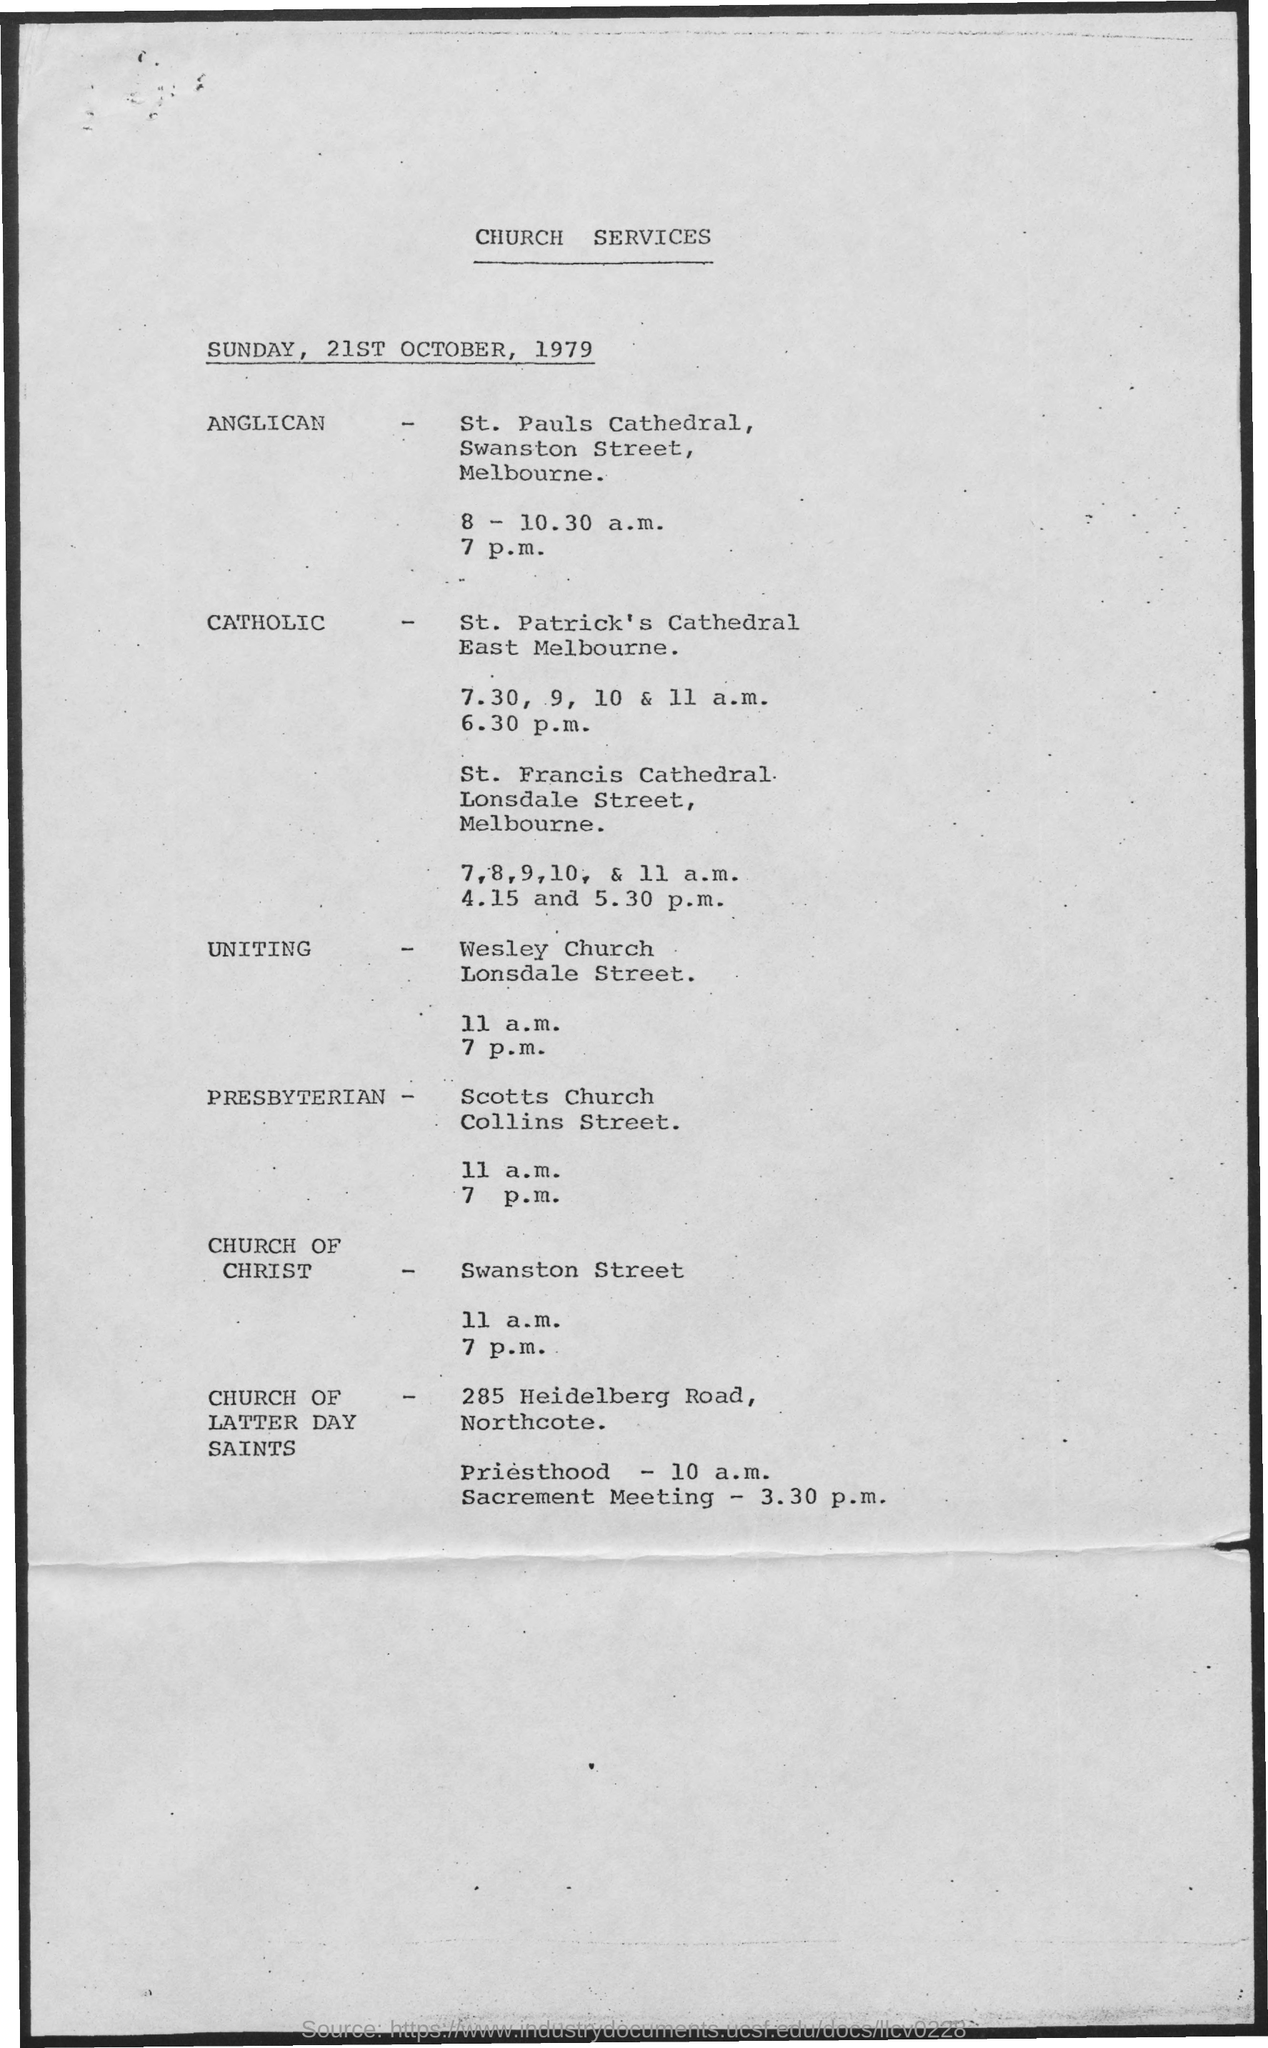What is the heading of document on top?
Ensure brevity in your answer.  Church Services. What day of the week is mentioned in the document?
Offer a terse response. Sunday. What is the date mentioned in document?
Make the answer very short. Sunday, 21st October, 1979. Where is church of Christ ?
Make the answer very short. Swanston Street. 